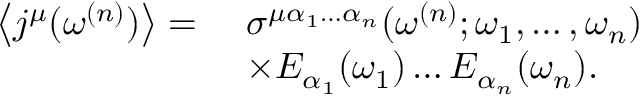<formula> <loc_0><loc_0><loc_500><loc_500>\begin{array} { r l } { \left \langle j ^ { \mu } ( \omega ^ { ( n ) } ) \right \rangle = \, } & { \sigma ^ { \mu \alpha _ { 1 } \hdots \alpha _ { n } } ( \omega ^ { ( n ) } ; \omega _ { 1 } , \hdots , \omega _ { n } ) } \\ & { \times E _ { \alpha _ { 1 } } ( \omega _ { 1 } ) \hdots E _ { \alpha _ { n } } ( \omega _ { n } ) . } \end{array}</formula> 